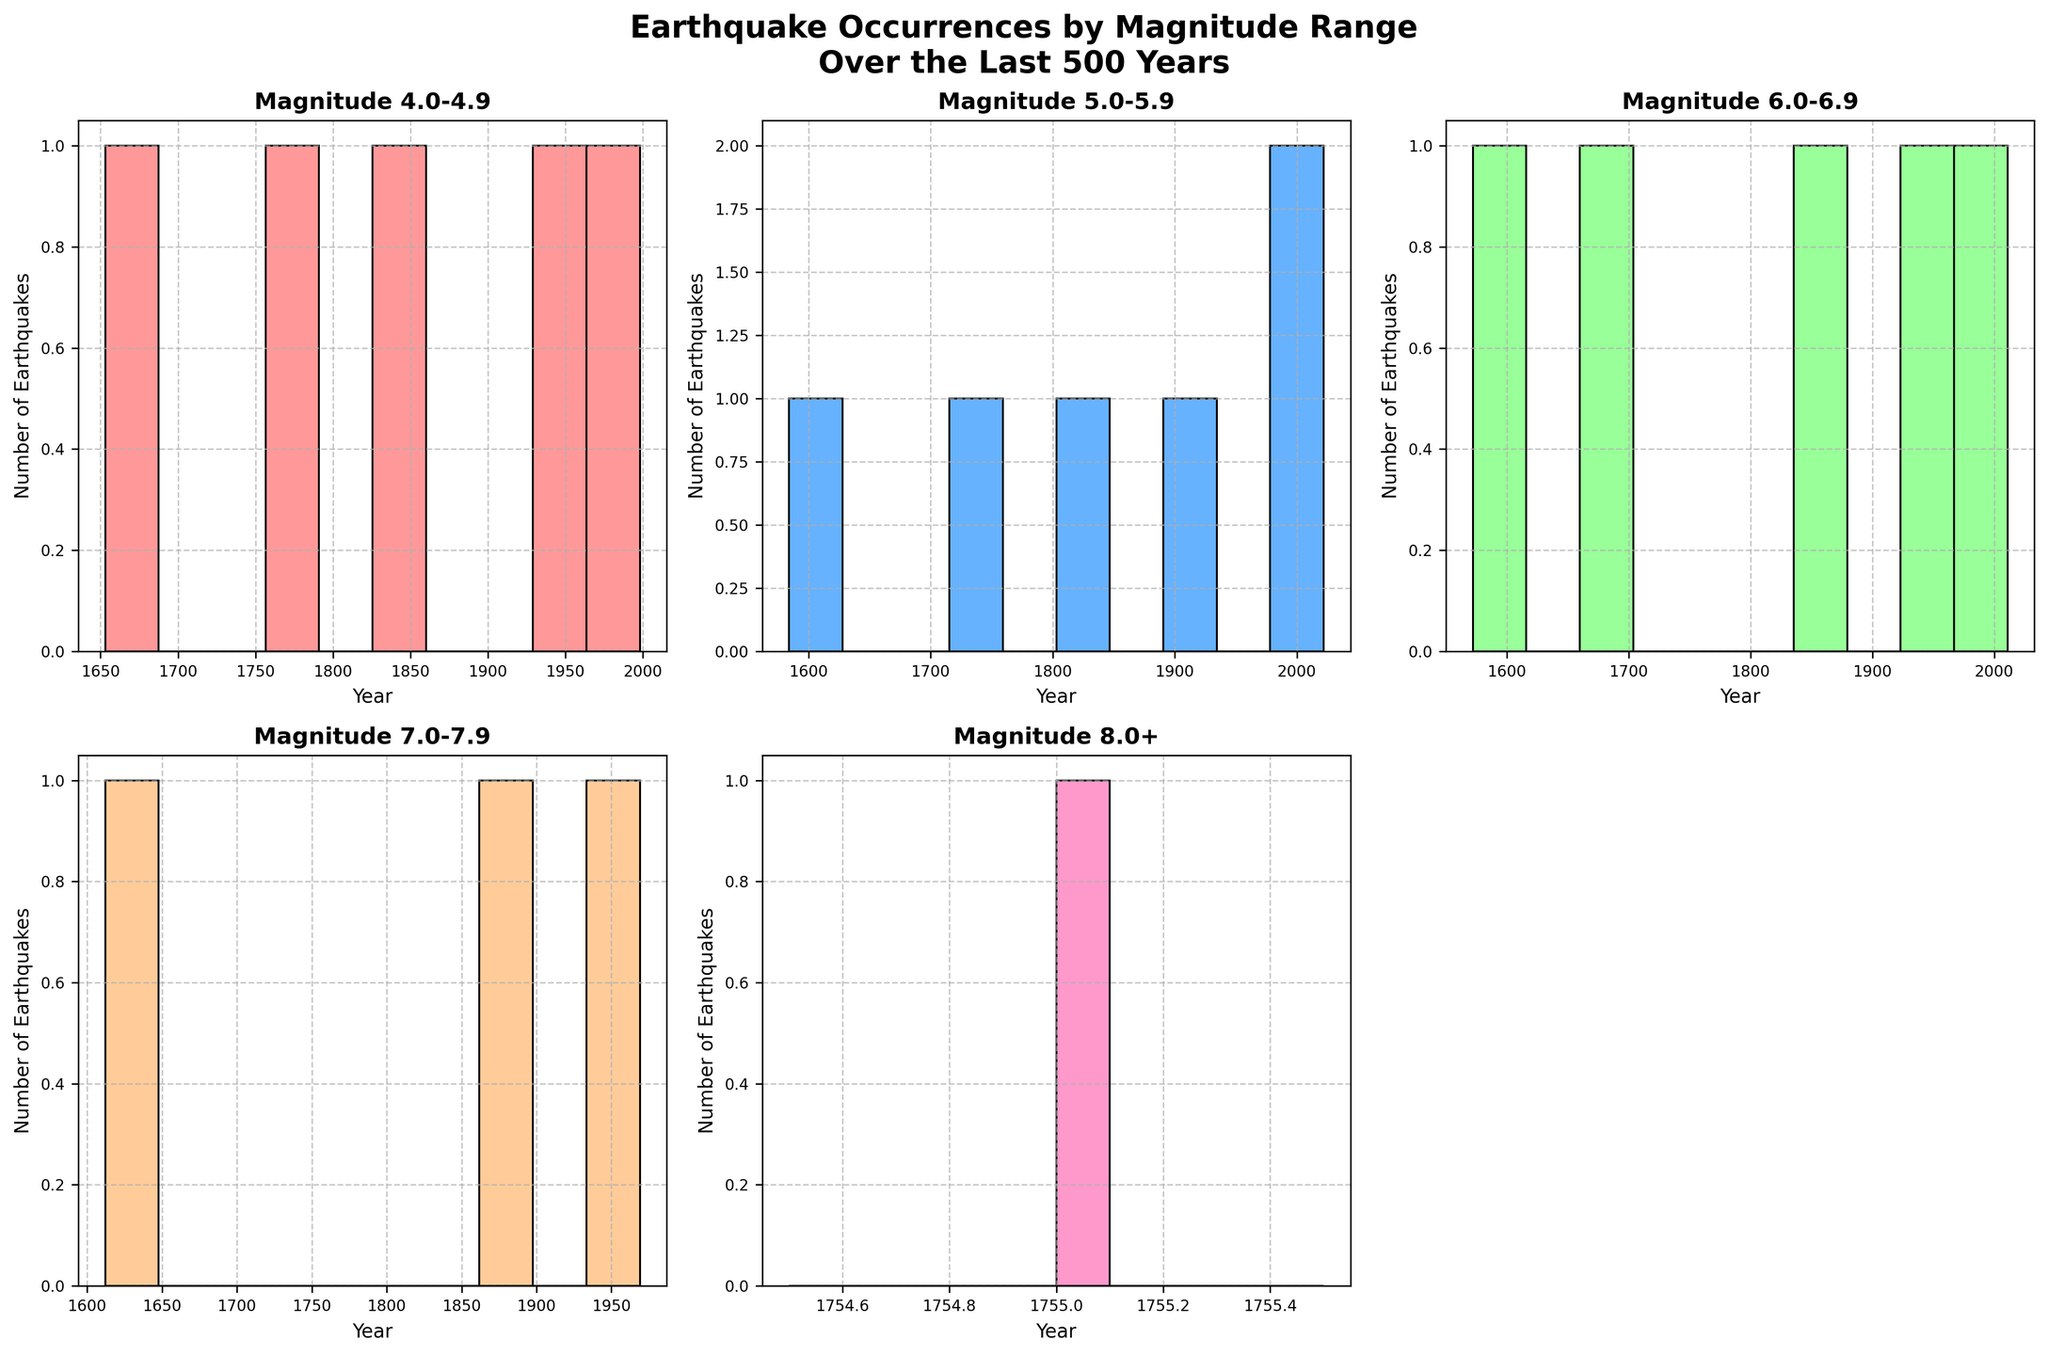What is the range of years covered in the subplot for magnitudes 6.0-6.9? The x-axis of the subplot for magnitudes 6.0-6.9 shows the earliest and latest years in the range. From the histogram, we see the earliest year is 1572 and the latest is 2011.
Answer: 1572-2011 How many earthquakes are in the 4.0-4.9 range? By counting the number of bars in the histogram labeled "Magnitude 4.0-4.9", we can see there are 5 bars, indicating a total of 5 earthquakes within this magnitude range.
Answer: 5 Which magnitude range has the highest number of earthquakes in the last 500 years? By comparing the histograms, the magnitude ranges 4.0-4.9 and 5.0-5.9 both have a significant number of earthquakes, but a detailed count shows 5 earthquakes in 4.0-4.9 and 6 earthquakes in 5.0-5.9. So, the 5.0-5.9 range is highest.
Answer: 5.0-5.9 In which century did the most earthquakes of magnitude 7.0-7.9 occur? By observing the bars, the century with the highest number of earthquakes in the 7.0-7.9 range is the 17th and 20th centuries, as they each have one noticeable bar for the years 1612 and 1969.
Answer: 17th and 20th centuries What is the most recent year shown in any of the subplots? By looking at the x-axes across the subplots, the latest year visible is 2022 in the 5.0-5.9 magnitude subplot.
Answer: 2022 Which magnitude range is missing a subplot in the figure? The subplots span the ranges of 4.0-4.9 to 8.0+, but one subplot is unused. By checking the histogram labels, it is clear that the subplot for the 3.0-3.9 range is missing.
Answer: 3.0-3.9 What was the magnitude range of the earthquake that occurred in 1755? By referencing the data, the earthquake in 1755 falls under the 8.0+ magnitude range, which is also reflected in the caveat of the histogram labeled "Magnitude 8.0+".
Answer: 8.0+ How many magnitude 6.0-6.9 earthquakes occurred between 1600 and 1800? In the range 6.0-6.9 histogram, count the bars that fall between the years 1600 and 1800; there are three bars for the years 1612, 1687, and 1726, indicating three such earthquakes.
Answer: 3 How many earthquakes with magnitude 5.0-5.9 occurred after the year 1900? Observing the magnitude 5.0-5.9 histogram, check the bars beyond 1900; the bars represent years 1902, 1983, and 2022, totaling three earthquakes.
Answer: 3 